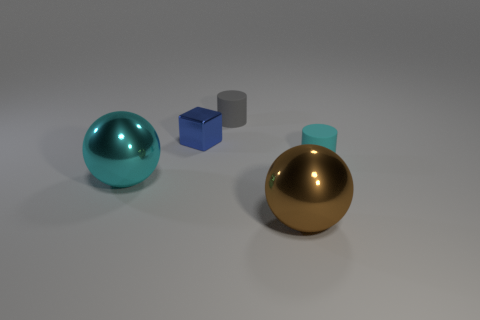Add 4 green shiny objects. How many objects exist? 9 Subtract all cubes. How many objects are left? 4 Subtract all matte cylinders. Subtract all small blue metal things. How many objects are left? 2 Add 5 cyan cylinders. How many cyan cylinders are left? 6 Add 1 brown things. How many brown things exist? 2 Subtract 0 cyan cubes. How many objects are left? 5 